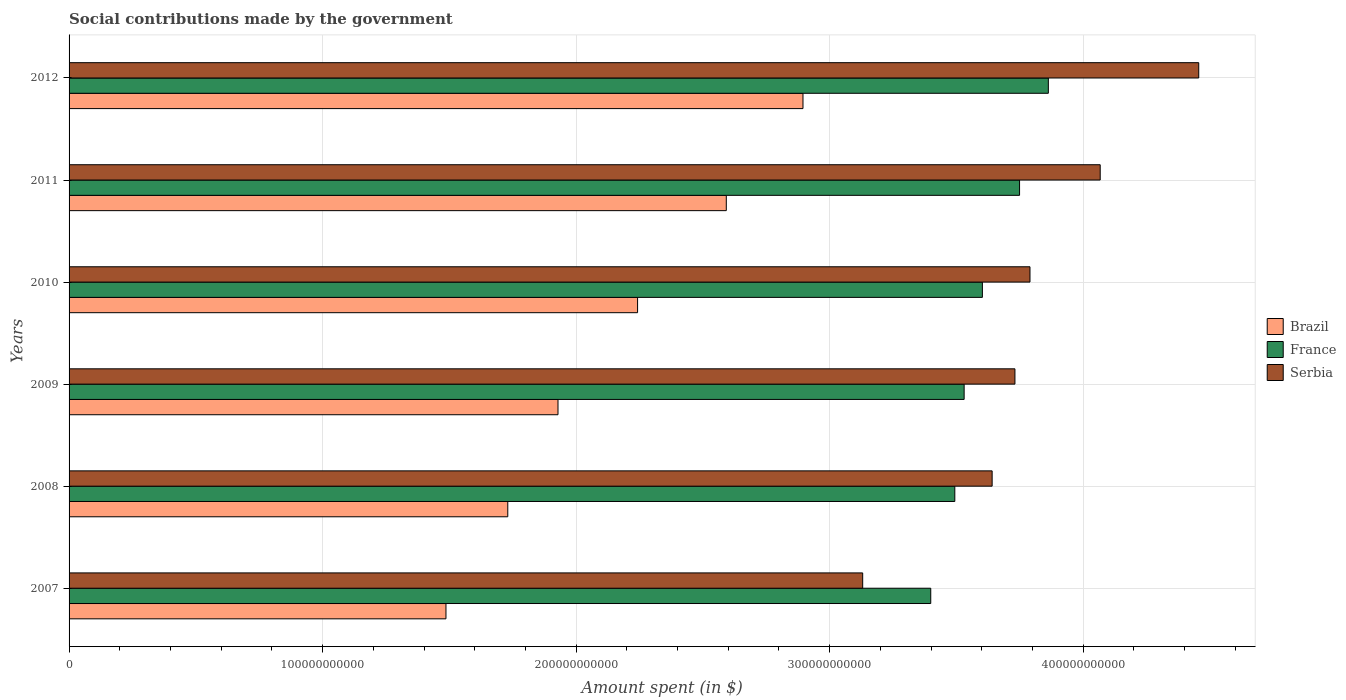How many different coloured bars are there?
Give a very brief answer. 3. How many groups of bars are there?
Keep it short and to the point. 6. Are the number of bars per tick equal to the number of legend labels?
Your answer should be compact. Yes. Are the number of bars on each tick of the Y-axis equal?
Offer a very short reply. Yes. How many bars are there on the 5th tick from the top?
Provide a succinct answer. 3. What is the label of the 6th group of bars from the top?
Ensure brevity in your answer.  2007. In how many cases, is the number of bars for a given year not equal to the number of legend labels?
Ensure brevity in your answer.  0. What is the amount spent on social contributions in France in 2012?
Offer a terse response. 3.86e+11. Across all years, what is the maximum amount spent on social contributions in Serbia?
Keep it short and to the point. 4.46e+11. Across all years, what is the minimum amount spent on social contributions in Serbia?
Your answer should be compact. 3.13e+11. What is the total amount spent on social contributions in Serbia in the graph?
Offer a terse response. 2.28e+12. What is the difference between the amount spent on social contributions in Brazil in 2010 and that in 2012?
Your answer should be compact. -6.52e+1. What is the difference between the amount spent on social contributions in Serbia in 2011 and the amount spent on social contributions in France in 2007?
Offer a terse response. 6.68e+1. What is the average amount spent on social contributions in Brazil per year?
Your answer should be compact. 2.15e+11. In the year 2008, what is the difference between the amount spent on social contributions in Serbia and amount spent on social contributions in France?
Ensure brevity in your answer.  1.47e+1. What is the ratio of the amount spent on social contributions in Serbia in 2011 to that in 2012?
Your answer should be compact. 0.91. Is the amount spent on social contributions in Serbia in 2007 less than that in 2011?
Provide a succinct answer. Yes. What is the difference between the highest and the second highest amount spent on social contributions in Serbia?
Give a very brief answer. 3.89e+1. What is the difference between the highest and the lowest amount spent on social contributions in Serbia?
Ensure brevity in your answer.  1.33e+11. In how many years, is the amount spent on social contributions in Serbia greater than the average amount spent on social contributions in Serbia taken over all years?
Your answer should be compact. 2. What does the 2nd bar from the bottom in 2012 represents?
Give a very brief answer. France. What is the difference between two consecutive major ticks on the X-axis?
Provide a succinct answer. 1.00e+11. Are the values on the major ticks of X-axis written in scientific E-notation?
Your answer should be compact. No. Does the graph contain any zero values?
Offer a very short reply. No. Does the graph contain grids?
Offer a terse response. Yes. What is the title of the graph?
Your answer should be compact. Social contributions made by the government. What is the label or title of the X-axis?
Give a very brief answer. Amount spent (in $). What is the Amount spent (in $) of Brazil in 2007?
Give a very brief answer. 1.49e+11. What is the Amount spent (in $) in France in 2007?
Your answer should be compact. 3.40e+11. What is the Amount spent (in $) of Serbia in 2007?
Provide a succinct answer. 3.13e+11. What is the Amount spent (in $) of Brazil in 2008?
Ensure brevity in your answer.  1.73e+11. What is the Amount spent (in $) in France in 2008?
Make the answer very short. 3.49e+11. What is the Amount spent (in $) of Serbia in 2008?
Your answer should be compact. 3.64e+11. What is the Amount spent (in $) of Brazil in 2009?
Your response must be concise. 1.93e+11. What is the Amount spent (in $) in France in 2009?
Provide a short and direct response. 3.53e+11. What is the Amount spent (in $) of Serbia in 2009?
Your answer should be very brief. 3.73e+11. What is the Amount spent (in $) of Brazil in 2010?
Keep it short and to the point. 2.24e+11. What is the Amount spent (in $) in France in 2010?
Provide a short and direct response. 3.60e+11. What is the Amount spent (in $) in Serbia in 2010?
Keep it short and to the point. 3.79e+11. What is the Amount spent (in $) in Brazil in 2011?
Make the answer very short. 2.59e+11. What is the Amount spent (in $) in France in 2011?
Give a very brief answer. 3.75e+11. What is the Amount spent (in $) of Serbia in 2011?
Offer a very short reply. 4.07e+11. What is the Amount spent (in $) of Brazil in 2012?
Your answer should be compact. 2.89e+11. What is the Amount spent (in $) in France in 2012?
Offer a very short reply. 3.86e+11. What is the Amount spent (in $) of Serbia in 2012?
Your response must be concise. 4.46e+11. Across all years, what is the maximum Amount spent (in $) in Brazil?
Your response must be concise. 2.89e+11. Across all years, what is the maximum Amount spent (in $) of France?
Make the answer very short. 3.86e+11. Across all years, what is the maximum Amount spent (in $) in Serbia?
Provide a short and direct response. 4.46e+11. Across all years, what is the minimum Amount spent (in $) of Brazil?
Keep it short and to the point. 1.49e+11. Across all years, what is the minimum Amount spent (in $) of France?
Keep it short and to the point. 3.40e+11. Across all years, what is the minimum Amount spent (in $) of Serbia?
Offer a terse response. 3.13e+11. What is the total Amount spent (in $) in Brazil in the graph?
Your response must be concise. 1.29e+12. What is the total Amount spent (in $) of France in the graph?
Give a very brief answer. 2.16e+12. What is the total Amount spent (in $) of Serbia in the graph?
Provide a succinct answer. 2.28e+12. What is the difference between the Amount spent (in $) of Brazil in 2007 and that in 2008?
Offer a terse response. -2.44e+1. What is the difference between the Amount spent (in $) in France in 2007 and that in 2008?
Your response must be concise. -9.49e+09. What is the difference between the Amount spent (in $) of Serbia in 2007 and that in 2008?
Offer a very short reply. -5.11e+1. What is the difference between the Amount spent (in $) in Brazil in 2007 and that in 2009?
Your response must be concise. -4.42e+1. What is the difference between the Amount spent (in $) of France in 2007 and that in 2009?
Your response must be concise. -1.32e+1. What is the difference between the Amount spent (in $) of Serbia in 2007 and that in 2009?
Make the answer very short. -6.00e+1. What is the difference between the Amount spent (in $) in Brazil in 2007 and that in 2010?
Give a very brief answer. -7.56e+1. What is the difference between the Amount spent (in $) of France in 2007 and that in 2010?
Your answer should be very brief. -2.04e+1. What is the difference between the Amount spent (in $) in Serbia in 2007 and that in 2010?
Your answer should be very brief. -6.60e+1. What is the difference between the Amount spent (in $) in Brazil in 2007 and that in 2011?
Provide a short and direct response. -1.11e+11. What is the difference between the Amount spent (in $) in France in 2007 and that in 2011?
Make the answer very short. -3.50e+1. What is the difference between the Amount spent (in $) in Serbia in 2007 and that in 2011?
Your answer should be very brief. -9.37e+1. What is the difference between the Amount spent (in $) in Brazil in 2007 and that in 2012?
Your answer should be very brief. -1.41e+11. What is the difference between the Amount spent (in $) of France in 2007 and that in 2012?
Your answer should be very brief. -4.64e+1. What is the difference between the Amount spent (in $) of Serbia in 2007 and that in 2012?
Offer a very short reply. -1.33e+11. What is the difference between the Amount spent (in $) of Brazil in 2008 and that in 2009?
Offer a very short reply. -1.98e+1. What is the difference between the Amount spent (in $) in France in 2008 and that in 2009?
Your answer should be very brief. -3.68e+09. What is the difference between the Amount spent (in $) in Serbia in 2008 and that in 2009?
Keep it short and to the point. -8.99e+09. What is the difference between the Amount spent (in $) in Brazil in 2008 and that in 2010?
Keep it short and to the point. -5.12e+1. What is the difference between the Amount spent (in $) in France in 2008 and that in 2010?
Keep it short and to the point. -1.09e+1. What is the difference between the Amount spent (in $) of Serbia in 2008 and that in 2010?
Offer a terse response. -1.49e+1. What is the difference between the Amount spent (in $) in Brazil in 2008 and that in 2011?
Offer a very short reply. -8.62e+1. What is the difference between the Amount spent (in $) of France in 2008 and that in 2011?
Provide a short and direct response. -2.55e+1. What is the difference between the Amount spent (in $) in Serbia in 2008 and that in 2011?
Ensure brevity in your answer.  -4.26e+1. What is the difference between the Amount spent (in $) of Brazil in 2008 and that in 2012?
Your response must be concise. -1.16e+11. What is the difference between the Amount spent (in $) of France in 2008 and that in 2012?
Give a very brief answer. -3.69e+1. What is the difference between the Amount spent (in $) in Serbia in 2008 and that in 2012?
Make the answer very short. -8.15e+1. What is the difference between the Amount spent (in $) in Brazil in 2009 and that in 2010?
Offer a very short reply. -3.14e+1. What is the difference between the Amount spent (in $) of France in 2009 and that in 2010?
Offer a very short reply. -7.20e+09. What is the difference between the Amount spent (in $) in Serbia in 2009 and that in 2010?
Provide a succinct answer. -5.94e+09. What is the difference between the Amount spent (in $) of Brazil in 2009 and that in 2011?
Provide a succinct answer. -6.64e+1. What is the difference between the Amount spent (in $) of France in 2009 and that in 2011?
Ensure brevity in your answer.  -2.19e+1. What is the difference between the Amount spent (in $) in Serbia in 2009 and that in 2011?
Your answer should be compact. -3.36e+1. What is the difference between the Amount spent (in $) of Brazil in 2009 and that in 2012?
Make the answer very short. -9.66e+1. What is the difference between the Amount spent (in $) of France in 2009 and that in 2012?
Your answer should be compact. -3.32e+1. What is the difference between the Amount spent (in $) of Serbia in 2009 and that in 2012?
Offer a very short reply. -7.25e+1. What is the difference between the Amount spent (in $) in Brazil in 2010 and that in 2011?
Provide a short and direct response. -3.50e+1. What is the difference between the Amount spent (in $) of France in 2010 and that in 2011?
Ensure brevity in your answer.  -1.47e+1. What is the difference between the Amount spent (in $) of Serbia in 2010 and that in 2011?
Offer a very short reply. -2.77e+1. What is the difference between the Amount spent (in $) in Brazil in 2010 and that in 2012?
Ensure brevity in your answer.  -6.52e+1. What is the difference between the Amount spent (in $) of France in 2010 and that in 2012?
Offer a very short reply. -2.60e+1. What is the difference between the Amount spent (in $) in Serbia in 2010 and that in 2012?
Provide a succinct answer. -6.66e+1. What is the difference between the Amount spent (in $) in Brazil in 2011 and that in 2012?
Keep it short and to the point. -3.02e+1. What is the difference between the Amount spent (in $) in France in 2011 and that in 2012?
Keep it short and to the point. -1.14e+1. What is the difference between the Amount spent (in $) in Serbia in 2011 and that in 2012?
Keep it short and to the point. -3.89e+1. What is the difference between the Amount spent (in $) of Brazil in 2007 and the Amount spent (in $) of France in 2008?
Make the answer very short. -2.01e+11. What is the difference between the Amount spent (in $) in Brazil in 2007 and the Amount spent (in $) in Serbia in 2008?
Your response must be concise. -2.15e+11. What is the difference between the Amount spent (in $) in France in 2007 and the Amount spent (in $) in Serbia in 2008?
Your response must be concise. -2.42e+1. What is the difference between the Amount spent (in $) in Brazil in 2007 and the Amount spent (in $) in France in 2009?
Your answer should be compact. -2.04e+11. What is the difference between the Amount spent (in $) of Brazil in 2007 and the Amount spent (in $) of Serbia in 2009?
Ensure brevity in your answer.  -2.24e+11. What is the difference between the Amount spent (in $) in France in 2007 and the Amount spent (in $) in Serbia in 2009?
Your answer should be compact. -3.32e+1. What is the difference between the Amount spent (in $) of Brazil in 2007 and the Amount spent (in $) of France in 2010?
Ensure brevity in your answer.  -2.12e+11. What is the difference between the Amount spent (in $) of Brazil in 2007 and the Amount spent (in $) of Serbia in 2010?
Keep it short and to the point. -2.30e+11. What is the difference between the Amount spent (in $) in France in 2007 and the Amount spent (in $) in Serbia in 2010?
Your answer should be compact. -3.91e+1. What is the difference between the Amount spent (in $) in Brazil in 2007 and the Amount spent (in $) in France in 2011?
Make the answer very short. -2.26e+11. What is the difference between the Amount spent (in $) in Brazil in 2007 and the Amount spent (in $) in Serbia in 2011?
Your response must be concise. -2.58e+11. What is the difference between the Amount spent (in $) in France in 2007 and the Amount spent (in $) in Serbia in 2011?
Provide a succinct answer. -6.68e+1. What is the difference between the Amount spent (in $) of Brazil in 2007 and the Amount spent (in $) of France in 2012?
Ensure brevity in your answer.  -2.38e+11. What is the difference between the Amount spent (in $) in Brazil in 2007 and the Amount spent (in $) in Serbia in 2012?
Offer a very short reply. -2.97e+11. What is the difference between the Amount spent (in $) of France in 2007 and the Amount spent (in $) of Serbia in 2012?
Keep it short and to the point. -1.06e+11. What is the difference between the Amount spent (in $) of Brazil in 2008 and the Amount spent (in $) of France in 2009?
Offer a very short reply. -1.80e+11. What is the difference between the Amount spent (in $) in Brazil in 2008 and the Amount spent (in $) in Serbia in 2009?
Give a very brief answer. -2.00e+11. What is the difference between the Amount spent (in $) of France in 2008 and the Amount spent (in $) of Serbia in 2009?
Your response must be concise. -2.37e+1. What is the difference between the Amount spent (in $) in Brazil in 2008 and the Amount spent (in $) in France in 2010?
Offer a terse response. -1.87e+11. What is the difference between the Amount spent (in $) of Brazil in 2008 and the Amount spent (in $) of Serbia in 2010?
Your answer should be very brief. -2.06e+11. What is the difference between the Amount spent (in $) in France in 2008 and the Amount spent (in $) in Serbia in 2010?
Give a very brief answer. -2.97e+1. What is the difference between the Amount spent (in $) of Brazil in 2008 and the Amount spent (in $) of France in 2011?
Your answer should be very brief. -2.02e+11. What is the difference between the Amount spent (in $) in Brazil in 2008 and the Amount spent (in $) in Serbia in 2011?
Your answer should be compact. -2.34e+11. What is the difference between the Amount spent (in $) in France in 2008 and the Amount spent (in $) in Serbia in 2011?
Offer a terse response. -5.73e+1. What is the difference between the Amount spent (in $) of Brazil in 2008 and the Amount spent (in $) of France in 2012?
Give a very brief answer. -2.13e+11. What is the difference between the Amount spent (in $) in Brazil in 2008 and the Amount spent (in $) in Serbia in 2012?
Give a very brief answer. -2.73e+11. What is the difference between the Amount spent (in $) in France in 2008 and the Amount spent (in $) in Serbia in 2012?
Offer a terse response. -9.62e+1. What is the difference between the Amount spent (in $) of Brazil in 2009 and the Amount spent (in $) of France in 2010?
Your answer should be compact. -1.67e+11. What is the difference between the Amount spent (in $) in Brazil in 2009 and the Amount spent (in $) in Serbia in 2010?
Your answer should be compact. -1.86e+11. What is the difference between the Amount spent (in $) in France in 2009 and the Amount spent (in $) in Serbia in 2010?
Offer a very short reply. -2.60e+1. What is the difference between the Amount spent (in $) of Brazil in 2009 and the Amount spent (in $) of France in 2011?
Your answer should be very brief. -1.82e+11. What is the difference between the Amount spent (in $) in Brazil in 2009 and the Amount spent (in $) in Serbia in 2011?
Your answer should be very brief. -2.14e+11. What is the difference between the Amount spent (in $) of France in 2009 and the Amount spent (in $) of Serbia in 2011?
Provide a succinct answer. -5.37e+1. What is the difference between the Amount spent (in $) in Brazil in 2009 and the Amount spent (in $) in France in 2012?
Give a very brief answer. -1.93e+11. What is the difference between the Amount spent (in $) in Brazil in 2009 and the Amount spent (in $) in Serbia in 2012?
Keep it short and to the point. -2.53e+11. What is the difference between the Amount spent (in $) of France in 2009 and the Amount spent (in $) of Serbia in 2012?
Offer a very short reply. -9.25e+1. What is the difference between the Amount spent (in $) of Brazil in 2010 and the Amount spent (in $) of France in 2011?
Offer a terse response. -1.51e+11. What is the difference between the Amount spent (in $) of Brazil in 2010 and the Amount spent (in $) of Serbia in 2011?
Keep it short and to the point. -1.82e+11. What is the difference between the Amount spent (in $) of France in 2010 and the Amount spent (in $) of Serbia in 2011?
Provide a short and direct response. -4.65e+1. What is the difference between the Amount spent (in $) of Brazil in 2010 and the Amount spent (in $) of France in 2012?
Offer a terse response. -1.62e+11. What is the difference between the Amount spent (in $) in Brazil in 2010 and the Amount spent (in $) in Serbia in 2012?
Provide a succinct answer. -2.21e+11. What is the difference between the Amount spent (in $) of France in 2010 and the Amount spent (in $) of Serbia in 2012?
Make the answer very short. -8.53e+1. What is the difference between the Amount spent (in $) in Brazil in 2011 and the Amount spent (in $) in France in 2012?
Offer a very short reply. -1.27e+11. What is the difference between the Amount spent (in $) in Brazil in 2011 and the Amount spent (in $) in Serbia in 2012?
Provide a succinct answer. -1.86e+11. What is the difference between the Amount spent (in $) in France in 2011 and the Amount spent (in $) in Serbia in 2012?
Your response must be concise. -7.07e+1. What is the average Amount spent (in $) in Brazil per year?
Offer a very short reply. 2.15e+11. What is the average Amount spent (in $) in France per year?
Give a very brief answer. 3.61e+11. What is the average Amount spent (in $) in Serbia per year?
Give a very brief answer. 3.80e+11. In the year 2007, what is the difference between the Amount spent (in $) in Brazil and Amount spent (in $) in France?
Keep it short and to the point. -1.91e+11. In the year 2007, what is the difference between the Amount spent (in $) in Brazil and Amount spent (in $) in Serbia?
Offer a very short reply. -1.64e+11. In the year 2007, what is the difference between the Amount spent (in $) of France and Amount spent (in $) of Serbia?
Keep it short and to the point. 2.68e+1. In the year 2008, what is the difference between the Amount spent (in $) of Brazil and Amount spent (in $) of France?
Offer a terse response. -1.76e+11. In the year 2008, what is the difference between the Amount spent (in $) in Brazil and Amount spent (in $) in Serbia?
Provide a succinct answer. -1.91e+11. In the year 2008, what is the difference between the Amount spent (in $) in France and Amount spent (in $) in Serbia?
Your answer should be very brief. -1.47e+1. In the year 2009, what is the difference between the Amount spent (in $) in Brazil and Amount spent (in $) in France?
Provide a short and direct response. -1.60e+11. In the year 2009, what is the difference between the Amount spent (in $) in Brazil and Amount spent (in $) in Serbia?
Offer a very short reply. -1.80e+11. In the year 2009, what is the difference between the Amount spent (in $) of France and Amount spent (in $) of Serbia?
Your answer should be very brief. -2.00e+1. In the year 2010, what is the difference between the Amount spent (in $) of Brazil and Amount spent (in $) of France?
Your answer should be very brief. -1.36e+11. In the year 2010, what is the difference between the Amount spent (in $) in Brazil and Amount spent (in $) in Serbia?
Your answer should be compact. -1.55e+11. In the year 2010, what is the difference between the Amount spent (in $) of France and Amount spent (in $) of Serbia?
Your response must be concise. -1.88e+1. In the year 2011, what is the difference between the Amount spent (in $) of Brazil and Amount spent (in $) of France?
Provide a short and direct response. -1.16e+11. In the year 2011, what is the difference between the Amount spent (in $) of Brazil and Amount spent (in $) of Serbia?
Give a very brief answer. -1.47e+11. In the year 2011, what is the difference between the Amount spent (in $) in France and Amount spent (in $) in Serbia?
Make the answer very short. -3.18e+1. In the year 2012, what is the difference between the Amount spent (in $) in Brazil and Amount spent (in $) in France?
Offer a terse response. -9.68e+1. In the year 2012, what is the difference between the Amount spent (in $) of Brazil and Amount spent (in $) of Serbia?
Offer a terse response. -1.56e+11. In the year 2012, what is the difference between the Amount spent (in $) in France and Amount spent (in $) in Serbia?
Offer a very short reply. -5.93e+1. What is the ratio of the Amount spent (in $) of Brazil in 2007 to that in 2008?
Offer a terse response. 0.86. What is the ratio of the Amount spent (in $) of France in 2007 to that in 2008?
Your response must be concise. 0.97. What is the ratio of the Amount spent (in $) of Serbia in 2007 to that in 2008?
Your response must be concise. 0.86. What is the ratio of the Amount spent (in $) in Brazil in 2007 to that in 2009?
Your response must be concise. 0.77. What is the ratio of the Amount spent (in $) in France in 2007 to that in 2009?
Your response must be concise. 0.96. What is the ratio of the Amount spent (in $) of Serbia in 2007 to that in 2009?
Your response must be concise. 0.84. What is the ratio of the Amount spent (in $) in Brazil in 2007 to that in 2010?
Keep it short and to the point. 0.66. What is the ratio of the Amount spent (in $) of France in 2007 to that in 2010?
Ensure brevity in your answer.  0.94. What is the ratio of the Amount spent (in $) of Serbia in 2007 to that in 2010?
Keep it short and to the point. 0.83. What is the ratio of the Amount spent (in $) in Brazil in 2007 to that in 2011?
Keep it short and to the point. 0.57. What is the ratio of the Amount spent (in $) of France in 2007 to that in 2011?
Make the answer very short. 0.91. What is the ratio of the Amount spent (in $) in Serbia in 2007 to that in 2011?
Offer a very short reply. 0.77. What is the ratio of the Amount spent (in $) in Brazil in 2007 to that in 2012?
Give a very brief answer. 0.51. What is the ratio of the Amount spent (in $) of France in 2007 to that in 2012?
Offer a very short reply. 0.88. What is the ratio of the Amount spent (in $) of Serbia in 2007 to that in 2012?
Keep it short and to the point. 0.7. What is the ratio of the Amount spent (in $) of Brazil in 2008 to that in 2009?
Ensure brevity in your answer.  0.9. What is the ratio of the Amount spent (in $) in France in 2008 to that in 2009?
Your answer should be compact. 0.99. What is the ratio of the Amount spent (in $) of Serbia in 2008 to that in 2009?
Provide a short and direct response. 0.98. What is the ratio of the Amount spent (in $) of Brazil in 2008 to that in 2010?
Offer a very short reply. 0.77. What is the ratio of the Amount spent (in $) of France in 2008 to that in 2010?
Provide a short and direct response. 0.97. What is the ratio of the Amount spent (in $) of Serbia in 2008 to that in 2010?
Keep it short and to the point. 0.96. What is the ratio of the Amount spent (in $) in Brazil in 2008 to that in 2011?
Offer a terse response. 0.67. What is the ratio of the Amount spent (in $) in France in 2008 to that in 2011?
Ensure brevity in your answer.  0.93. What is the ratio of the Amount spent (in $) of Serbia in 2008 to that in 2011?
Make the answer very short. 0.9. What is the ratio of the Amount spent (in $) in Brazil in 2008 to that in 2012?
Your response must be concise. 0.6. What is the ratio of the Amount spent (in $) in France in 2008 to that in 2012?
Your answer should be very brief. 0.9. What is the ratio of the Amount spent (in $) of Serbia in 2008 to that in 2012?
Provide a succinct answer. 0.82. What is the ratio of the Amount spent (in $) of Brazil in 2009 to that in 2010?
Your answer should be very brief. 0.86. What is the ratio of the Amount spent (in $) in Serbia in 2009 to that in 2010?
Give a very brief answer. 0.98. What is the ratio of the Amount spent (in $) in Brazil in 2009 to that in 2011?
Provide a short and direct response. 0.74. What is the ratio of the Amount spent (in $) of France in 2009 to that in 2011?
Give a very brief answer. 0.94. What is the ratio of the Amount spent (in $) of Serbia in 2009 to that in 2011?
Give a very brief answer. 0.92. What is the ratio of the Amount spent (in $) of Brazil in 2009 to that in 2012?
Your answer should be compact. 0.67. What is the ratio of the Amount spent (in $) in France in 2009 to that in 2012?
Provide a succinct answer. 0.91. What is the ratio of the Amount spent (in $) in Serbia in 2009 to that in 2012?
Give a very brief answer. 0.84. What is the ratio of the Amount spent (in $) of Brazil in 2010 to that in 2011?
Your response must be concise. 0.86. What is the ratio of the Amount spent (in $) in France in 2010 to that in 2011?
Make the answer very short. 0.96. What is the ratio of the Amount spent (in $) in Serbia in 2010 to that in 2011?
Provide a short and direct response. 0.93. What is the ratio of the Amount spent (in $) in Brazil in 2010 to that in 2012?
Provide a short and direct response. 0.77. What is the ratio of the Amount spent (in $) in France in 2010 to that in 2012?
Keep it short and to the point. 0.93. What is the ratio of the Amount spent (in $) in Serbia in 2010 to that in 2012?
Your response must be concise. 0.85. What is the ratio of the Amount spent (in $) in Brazil in 2011 to that in 2012?
Provide a short and direct response. 0.9. What is the ratio of the Amount spent (in $) in France in 2011 to that in 2012?
Give a very brief answer. 0.97. What is the ratio of the Amount spent (in $) in Serbia in 2011 to that in 2012?
Make the answer very short. 0.91. What is the difference between the highest and the second highest Amount spent (in $) of Brazil?
Your response must be concise. 3.02e+1. What is the difference between the highest and the second highest Amount spent (in $) in France?
Make the answer very short. 1.14e+1. What is the difference between the highest and the second highest Amount spent (in $) in Serbia?
Provide a short and direct response. 3.89e+1. What is the difference between the highest and the lowest Amount spent (in $) in Brazil?
Provide a succinct answer. 1.41e+11. What is the difference between the highest and the lowest Amount spent (in $) in France?
Your answer should be compact. 4.64e+1. What is the difference between the highest and the lowest Amount spent (in $) of Serbia?
Ensure brevity in your answer.  1.33e+11. 